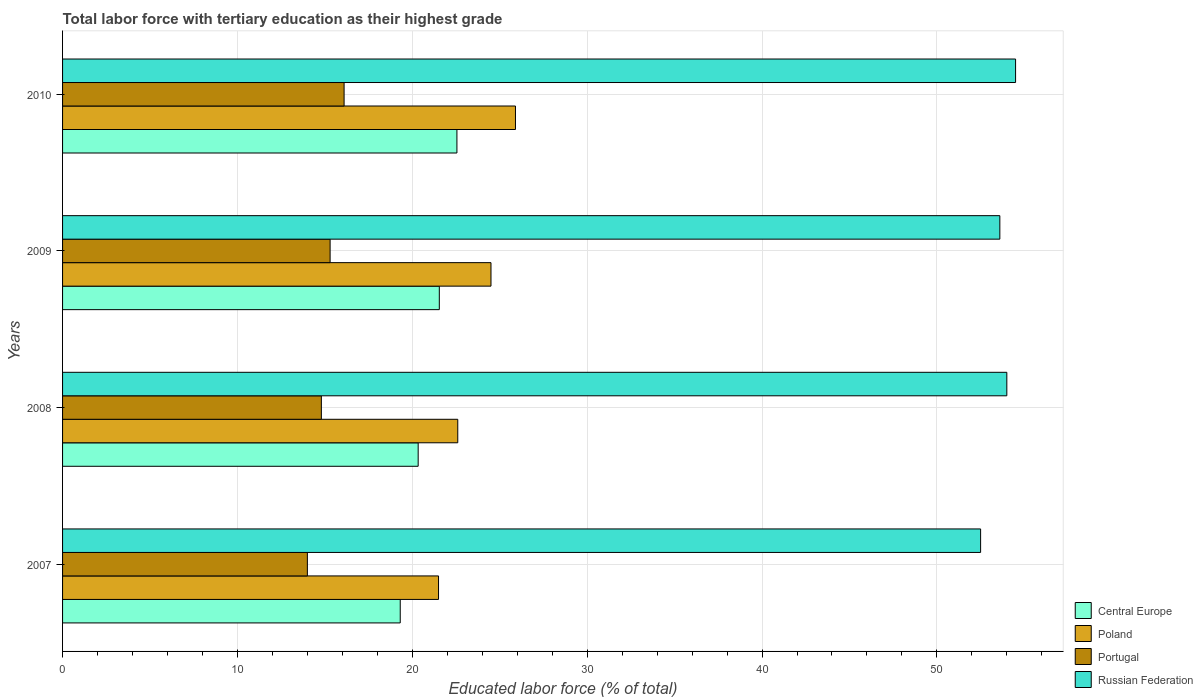How many different coloured bars are there?
Your answer should be compact. 4. How many bars are there on the 4th tick from the top?
Your answer should be very brief. 4. In how many cases, is the number of bars for a given year not equal to the number of legend labels?
Offer a terse response. 0. What is the percentage of male labor force with tertiary education in Central Europe in 2009?
Your response must be concise. 21.55. Across all years, what is the maximum percentage of male labor force with tertiary education in Central Europe?
Your answer should be very brief. 22.55. Across all years, what is the minimum percentage of male labor force with tertiary education in Central Europe?
Your answer should be compact. 19.31. In which year was the percentage of male labor force with tertiary education in Central Europe maximum?
Provide a short and direct response. 2010. In which year was the percentage of male labor force with tertiary education in Poland minimum?
Your answer should be compact. 2007. What is the total percentage of male labor force with tertiary education in Portugal in the graph?
Give a very brief answer. 60.2. What is the difference between the percentage of male labor force with tertiary education in Russian Federation in 2007 and that in 2009?
Ensure brevity in your answer.  -1.1. What is the difference between the percentage of male labor force with tertiary education in Russian Federation in 2009 and the percentage of male labor force with tertiary education in Poland in 2008?
Keep it short and to the point. 31. What is the average percentage of male labor force with tertiary education in Portugal per year?
Ensure brevity in your answer.  15.05. In the year 2007, what is the difference between the percentage of male labor force with tertiary education in Russian Federation and percentage of male labor force with tertiary education in Portugal?
Offer a terse response. 38.5. In how many years, is the percentage of male labor force with tertiary education in Central Europe greater than 40 %?
Give a very brief answer. 0. What is the ratio of the percentage of male labor force with tertiary education in Portugal in 2008 to that in 2010?
Provide a short and direct response. 0.92. Is the percentage of male labor force with tertiary education in Central Europe in 2007 less than that in 2008?
Give a very brief answer. Yes. What is the difference between the highest and the second highest percentage of male labor force with tertiary education in Central Europe?
Your response must be concise. 1.01. What is the difference between the highest and the lowest percentage of male labor force with tertiary education in Russian Federation?
Make the answer very short. 2. In how many years, is the percentage of male labor force with tertiary education in Portugal greater than the average percentage of male labor force with tertiary education in Portugal taken over all years?
Provide a succinct answer. 2. What does the 2nd bar from the top in 2008 represents?
Ensure brevity in your answer.  Portugal. What does the 4th bar from the bottom in 2007 represents?
Give a very brief answer. Russian Federation. How many bars are there?
Your answer should be very brief. 16. Does the graph contain any zero values?
Ensure brevity in your answer.  No. What is the title of the graph?
Your response must be concise. Total labor force with tertiary education as their highest grade. What is the label or title of the X-axis?
Your response must be concise. Educated labor force (% of total). What is the Educated labor force (% of total) of Central Europe in 2007?
Make the answer very short. 19.31. What is the Educated labor force (% of total) of Portugal in 2007?
Provide a short and direct response. 14. What is the Educated labor force (% of total) of Russian Federation in 2007?
Provide a short and direct response. 52.5. What is the Educated labor force (% of total) in Central Europe in 2008?
Keep it short and to the point. 20.34. What is the Educated labor force (% of total) of Poland in 2008?
Provide a short and direct response. 22.6. What is the Educated labor force (% of total) in Portugal in 2008?
Offer a very short reply. 14.8. What is the Educated labor force (% of total) of Central Europe in 2009?
Give a very brief answer. 21.55. What is the Educated labor force (% of total) of Poland in 2009?
Your response must be concise. 24.5. What is the Educated labor force (% of total) in Portugal in 2009?
Make the answer very short. 15.3. What is the Educated labor force (% of total) in Russian Federation in 2009?
Your response must be concise. 53.6. What is the Educated labor force (% of total) in Central Europe in 2010?
Provide a succinct answer. 22.55. What is the Educated labor force (% of total) of Poland in 2010?
Offer a terse response. 25.9. What is the Educated labor force (% of total) in Portugal in 2010?
Keep it short and to the point. 16.1. What is the Educated labor force (% of total) in Russian Federation in 2010?
Ensure brevity in your answer.  54.5. Across all years, what is the maximum Educated labor force (% of total) of Central Europe?
Ensure brevity in your answer.  22.55. Across all years, what is the maximum Educated labor force (% of total) of Poland?
Provide a short and direct response. 25.9. Across all years, what is the maximum Educated labor force (% of total) in Portugal?
Provide a succinct answer. 16.1. Across all years, what is the maximum Educated labor force (% of total) of Russian Federation?
Keep it short and to the point. 54.5. Across all years, what is the minimum Educated labor force (% of total) in Central Europe?
Your answer should be compact. 19.31. Across all years, what is the minimum Educated labor force (% of total) in Poland?
Offer a very short reply. 21.5. Across all years, what is the minimum Educated labor force (% of total) in Russian Federation?
Provide a short and direct response. 52.5. What is the total Educated labor force (% of total) of Central Europe in the graph?
Your answer should be very brief. 83.74. What is the total Educated labor force (% of total) of Poland in the graph?
Ensure brevity in your answer.  94.5. What is the total Educated labor force (% of total) in Portugal in the graph?
Provide a succinct answer. 60.2. What is the total Educated labor force (% of total) in Russian Federation in the graph?
Make the answer very short. 214.6. What is the difference between the Educated labor force (% of total) of Central Europe in 2007 and that in 2008?
Offer a very short reply. -1.03. What is the difference between the Educated labor force (% of total) of Poland in 2007 and that in 2008?
Your response must be concise. -1.1. What is the difference between the Educated labor force (% of total) in Central Europe in 2007 and that in 2009?
Make the answer very short. -2.23. What is the difference between the Educated labor force (% of total) of Poland in 2007 and that in 2009?
Keep it short and to the point. -3. What is the difference between the Educated labor force (% of total) of Portugal in 2007 and that in 2009?
Provide a succinct answer. -1.3. What is the difference between the Educated labor force (% of total) in Central Europe in 2007 and that in 2010?
Ensure brevity in your answer.  -3.24. What is the difference between the Educated labor force (% of total) in Russian Federation in 2007 and that in 2010?
Ensure brevity in your answer.  -2. What is the difference between the Educated labor force (% of total) in Central Europe in 2008 and that in 2009?
Offer a terse response. -1.21. What is the difference between the Educated labor force (% of total) in Poland in 2008 and that in 2009?
Provide a short and direct response. -1.9. What is the difference between the Educated labor force (% of total) in Portugal in 2008 and that in 2009?
Offer a very short reply. -0.5. What is the difference between the Educated labor force (% of total) in Russian Federation in 2008 and that in 2009?
Ensure brevity in your answer.  0.4. What is the difference between the Educated labor force (% of total) in Central Europe in 2008 and that in 2010?
Keep it short and to the point. -2.22. What is the difference between the Educated labor force (% of total) of Portugal in 2008 and that in 2010?
Your response must be concise. -1.3. What is the difference between the Educated labor force (% of total) of Central Europe in 2009 and that in 2010?
Your answer should be compact. -1.01. What is the difference between the Educated labor force (% of total) in Portugal in 2009 and that in 2010?
Your answer should be very brief. -0.8. What is the difference between the Educated labor force (% of total) in Central Europe in 2007 and the Educated labor force (% of total) in Poland in 2008?
Your answer should be compact. -3.29. What is the difference between the Educated labor force (% of total) of Central Europe in 2007 and the Educated labor force (% of total) of Portugal in 2008?
Make the answer very short. 4.51. What is the difference between the Educated labor force (% of total) in Central Europe in 2007 and the Educated labor force (% of total) in Russian Federation in 2008?
Your answer should be compact. -34.69. What is the difference between the Educated labor force (% of total) in Poland in 2007 and the Educated labor force (% of total) in Portugal in 2008?
Your response must be concise. 6.7. What is the difference between the Educated labor force (% of total) in Poland in 2007 and the Educated labor force (% of total) in Russian Federation in 2008?
Your answer should be compact. -32.5. What is the difference between the Educated labor force (% of total) of Portugal in 2007 and the Educated labor force (% of total) of Russian Federation in 2008?
Your answer should be compact. -40. What is the difference between the Educated labor force (% of total) of Central Europe in 2007 and the Educated labor force (% of total) of Poland in 2009?
Keep it short and to the point. -5.19. What is the difference between the Educated labor force (% of total) of Central Europe in 2007 and the Educated labor force (% of total) of Portugal in 2009?
Your answer should be very brief. 4.01. What is the difference between the Educated labor force (% of total) in Central Europe in 2007 and the Educated labor force (% of total) in Russian Federation in 2009?
Offer a very short reply. -34.29. What is the difference between the Educated labor force (% of total) of Poland in 2007 and the Educated labor force (% of total) of Russian Federation in 2009?
Keep it short and to the point. -32.1. What is the difference between the Educated labor force (% of total) in Portugal in 2007 and the Educated labor force (% of total) in Russian Federation in 2009?
Your answer should be very brief. -39.6. What is the difference between the Educated labor force (% of total) of Central Europe in 2007 and the Educated labor force (% of total) of Poland in 2010?
Make the answer very short. -6.59. What is the difference between the Educated labor force (% of total) in Central Europe in 2007 and the Educated labor force (% of total) in Portugal in 2010?
Provide a short and direct response. 3.21. What is the difference between the Educated labor force (% of total) of Central Europe in 2007 and the Educated labor force (% of total) of Russian Federation in 2010?
Ensure brevity in your answer.  -35.19. What is the difference between the Educated labor force (% of total) in Poland in 2007 and the Educated labor force (% of total) in Portugal in 2010?
Make the answer very short. 5.4. What is the difference between the Educated labor force (% of total) in Poland in 2007 and the Educated labor force (% of total) in Russian Federation in 2010?
Your response must be concise. -33. What is the difference between the Educated labor force (% of total) of Portugal in 2007 and the Educated labor force (% of total) of Russian Federation in 2010?
Make the answer very short. -40.5. What is the difference between the Educated labor force (% of total) of Central Europe in 2008 and the Educated labor force (% of total) of Poland in 2009?
Provide a short and direct response. -4.16. What is the difference between the Educated labor force (% of total) in Central Europe in 2008 and the Educated labor force (% of total) in Portugal in 2009?
Provide a succinct answer. 5.04. What is the difference between the Educated labor force (% of total) of Central Europe in 2008 and the Educated labor force (% of total) of Russian Federation in 2009?
Your answer should be compact. -33.26. What is the difference between the Educated labor force (% of total) of Poland in 2008 and the Educated labor force (% of total) of Portugal in 2009?
Your response must be concise. 7.3. What is the difference between the Educated labor force (% of total) of Poland in 2008 and the Educated labor force (% of total) of Russian Federation in 2009?
Make the answer very short. -31. What is the difference between the Educated labor force (% of total) of Portugal in 2008 and the Educated labor force (% of total) of Russian Federation in 2009?
Ensure brevity in your answer.  -38.8. What is the difference between the Educated labor force (% of total) of Central Europe in 2008 and the Educated labor force (% of total) of Poland in 2010?
Provide a short and direct response. -5.56. What is the difference between the Educated labor force (% of total) in Central Europe in 2008 and the Educated labor force (% of total) in Portugal in 2010?
Give a very brief answer. 4.24. What is the difference between the Educated labor force (% of total) of Central Europe in 2008 and the Educated labor force (% of total) of Russian Federation in 2010?
Offer a terse response. -34.16. What is the difference between the Educated labor force (% of total) of Poland in 2008 and the Educated labor force (% of total) of Russian Federation in 2010?
Offer a terse response. -31.9. What is the difference between the Educated labor force (% of total) of Portugal in 2008 and the Educated labor force (% of total) of Russian Federation in 2010?
Offer a terse response. -39.7. What is the difference between the Educated labor force (% of total) of Central Europe in 2009 and the Educated labor force (% of total) of Poland in 2010?
Your response must be concise. -4.35. What is the difference between the Educated labor force (% of total) of Central Europe in 2009 and the Educated labor force (% of total) of Portugal in 2010?
Keep it short and to the point. 5.45. What is the difference between the Educated labor force (% of total) of Central Europe in 2009 and the Educated labor force (% of total) of Russian Federation in 2010?
Your answer should be compact. -32.95. What is the difference between the Educated labor force (% of total) in Poland in 2009 and the Educated labor force (% of total) in Russian Federation in 2010?
Provide a succinct answer. -30. What is the difference between the Educated labor force (% of total) in Portugal in 2009 and the Educated labor force (% of total) in Russian Federation in 2010?
Offer a very short reply. -39.2. What is the average Educated labor force (% of total) of Central Europe per year?
Offer a terse response. 20.94. What is the average Educated labor force (% of total) in Poland per year?
Your response must be concise. 23.62. What is the average Educated labor force (% of total) in Portugal per year?
Provide a short and direct response. 15.05. What is the average Educated labor force (% of total) in Russian Federation per year?
Your answer should be compact. 53.65. In the year 2007, what is the difference between the Educated labor force (% of total) in Central Europe and Educated labor force (% of total) in Poland?
Give a very brief answer. -2.19. In the year 2007, what is the difference between the Educated labor force (% of total) in Central Europe and Educated labor force (% of total) in Portugal?
Provide a short and direct response. 5.31. In the year 2007, what is the difference between the Educated labor force (% of total) in Central Europe and Educated labor force (% of total) in Russian Federation?
Your answer should be compact. -33.19. In the year 2007, what is the difference between the Educated labor force (% of total) of Poland and Educated labor force (% of total) of Russian Federation?
Make the answer very short. -31. In the year 2007, what is the difference between the Educated labor force (% of total) in Portugal and Educated labor force (% of total) in Russian Federation?
Give a very brief answer. -38.5. In the year 2008, what is the difference between the Educated labor force (% of total) of Central Europe and Educated labor force (% of total) of Poland?
Your answer should be compact. -2.26. In the year 2008, what is the difference between the Educated labor force (% of total) of Central Europe and Educated labor force (% of total) of Portugal?
Make the answer very short. 5.54. In the year 2008, what is the difference between the Educated labor force (% of total) in Central Europe and Educated labor force (% of total) in Russian Federation?
Offer a terse response. -33.66. In the year 2008, what is the difference between the Educated labor force (% of total) in Poland and Educated labor force (% of total) in Russian Federation?
Provide a short and direct response. -31.4. In the year 2008, what is the difference between the Educated labor force (% of total) in Portugal and Educated labor force (% of total) in Russian Federation?
Provide a succinct answer. -39.2. In the year 2009, what is the difference between the Educated labor force (% of total) of Central Europe and Educated labor force (% of total) of Poland?
Your answer should be compact. -2.95. In the year 2009, what is the difference between the Educated labor force (% of total) in Central Europe and Educated labor force (% of total) in Portugal?
Your answer should be compact. 6.25. In the year 2009, what is the difference between the Educated labor force (% of total) in Central Europe and Educated labor force (% of total) in Russian Federation?
Your answer should be very brief. -32.05. In the year 2009, what is the difference between the Educated labor force (% of total) in Poland and Educated labor force (% of total) in Russian Federation?
Offer a very short reply. -29.1. In the year 2009, what is the difference between the Educated labor force (% of total) of Portugal and Educated labor force (% of total) of Russian Federation?
Your answer should be compact. -38.3. In the year 2010, what is the difference between the Educated labor force (% of total) in Central Europe and Educated labor force (% of total) in Poland?
Offer a very short reply. -3.35. In the year 2010, what is the difference between the Educated labor force (% of total) of Central Europe and Educated labor force (% of total) of Portugal?
Make the answer very short. 6.45. In the year 2010, what is the difference between the Educated labor force (% of total) of Central Europe and Educated labor force (% of total) of Russian Federation?
Keep it short and to the point. -31.95. In the year 2010, what is the difference between the Educated labor force (% of total) in Poland and Educated labor force (% of total) in Russian Federation?
Make the answer very short. -28.6. In the year 2010, what is the difference between the Educated labor force (% of total) of Portugal and Educated labor force (% of total) of Russian Federation?
Provide a short and direct response. -38.4. What is the ratio of the Educated labor force (% of total) in Central Europe in 2007 to that in 2008?
Provide a succinct answer. 0.95. What is the ratio of the Educated labor force (% of total) of Poland in 2007 to that in 2008?
Offer a very short reply. 0.95. What is the ratio of the Educated labor force (% of total) in Portugal in 2007 to that in 2008?
Keep it short and to the point. 0.95. What is the ratio of the Educated labor force (% of total) in Russian Federation in 2007 to that in 2008?
Make the answer very short. 0.97. What is the ratio of the Educated labor force (% of total) in Central Europe in 2007 to that in 2009?
Offer a very short reply. 0.9. What is the ratio of the Educated labor force (% of total) in Poland in 2007 to that in 2009?
Offer a terse response. 0.88. What is the ratio of the Educated labor force (% of total) in Portugal in 2007 to that in 2009?
Your response must be concise. 0.92. What is the ratio of the Educated labor force (% of total) of Russian Federation in 2007 to that in 2009?
Offer a very short reply. 0.98. What is the ratio of the Educated labor force (% of total) in Central Europe in 2007 to that in 2010?
Make the answer very short. 0.86. What is the ratio of the Educated labor force (% of total) in Poland in 2007 to that in 2010?
Make the answer very short. 0.83. What is the ratio of the Educated labor force (% of total) of Portugal in 2007 to that in 2010?
Make the answer very short. 0.87. What is the ratio of the Educated labor force (% of total) of Russian Federation in 2007 to that in 2010?
Keep it short and to the point. 0.96. What is the ratio of the Educated labor force (% of total) of Central Europe in 2008 to that in 2009?
Ensure brevity in your answer.  0.94. What is the ratio of the Educated labor force (% of total) in Poland in 2008 to that in 2009?
Your answer should be compact. 0.92. What is the ratio of the Educated labor force (% of total) in Portugal in 2008 to that in 2009?
Your response must be concise. 0.97. What is the ratio of the Educated labor force (% of total) of Russian Federation in 2008 to that in 2009?
Offer a very short reply. 1.01. What is the ratio of the Educated labor force (% of total) of Central Europe in 2008 to that in 2010?
Your response must be concise. 0.9. What is the ratio of the Educated labor force (% of total) in Poland in 2008 to that in 2010?
Your answer should be compact. 0.87. What is the ratio of the Educated labor force (% of total) in Portugal in 2008 to that in 2010?
Give a very brief answer. 0.92. What is the ratio of the Educated labor force (% of total) in Russian Federation in 2008 to that in 2010?
Make the answer very short. 0.99. What is the ratio of the Educated labor force (% of total) in Central Europe in 2009 to that in 2010?
Your answer should be compact. 0.96. What is the ratio of the Educated labor force (% of total) of Poland in 2009 to that in 2010?
Your response must be concise. 0.95. What is the ratio of the Educated labor force (% of total) in Portugal in 2009 to that in 2010?
Your answer should be very brief. 0.95. What is the ratio of the Educated labor force (% of total) in Russian Federation in 2009 to that in 2010?
Give a very brief answer. 0.98. What is the difference between the highest and the second highest Educated labor force (% of total) of Portugal?
Offer a very short reply. 0.8. What is the difference between the highest and the lowest Educated labor force (% of total) of Central Europe?
Offer a terse response. 3.24. 